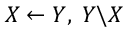<formula> <loc_0><loc_0><loc_500><loc_500>X \leftarrow Y , \, Y \ X</formula> 